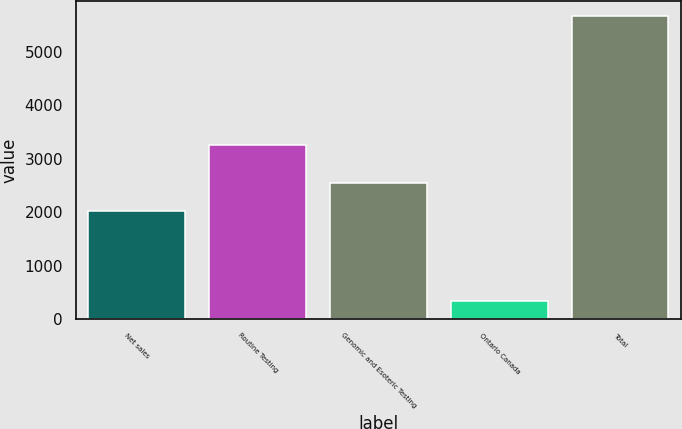Convert chart to OTSL. <chart><loc_0><loc_0><loc_500><loc_500><bar_chart><fcel>Net sales<fcel>Routine Testing<fcel>Genomic and Esoteric Testing<fcel>Ontario Canada<fcel>Total<nl><fcel>2012<fcel>3246.6<fcel>2545.64<fcel>335<fcel>5671.4<nl></chart> 